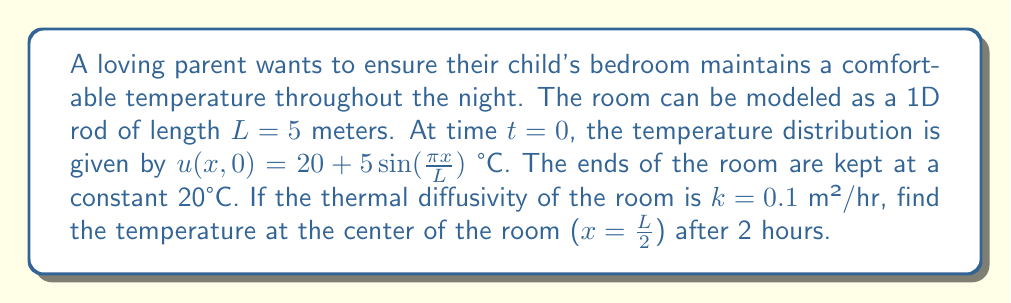Can you solve this math problem? To solve this problem, we'll use the heat equation in one dimension:

$$\frac{\partial u}{\partial t} = k\frac{\partial^2 u}{\partial x^2}$$

Given conditions:
- Initial condition: $u(x,0) = 20 + 5\sin(\frac{\pi x}{L})$
- Boundary conditions: $u(0,t) = u(L,t) = 20$
- $L = 5$ m, $k = 0.1$ m²/hr, $t = 2$ hr, $x = \frac{L}{2} = 2.5$ m

Step 1: The solution to the heat equation with these boundary conditions is:

$$u(x,t) = 20 + \sum_{n=1}^{\infty} B_n \sin(\frac{n\pi x}{L})e^{-k(\frac{n\pi}{L})^2t}$$

Step 2: Find $B_n$ using the initial condition:

$$B_n = \frac{2}{L}\int_0^L (u(x,0) - 20)\sin(\frac{n\pi x}{L})dx$$

$$B_n = \frac{2}{L}\int_0^L 5\sin(\frac{\pi x}{L})\sin(\frac{n\pi x}{L})dx$$

This integral is non-zero only when $n=1$, giving $B_1 = 5$ and $B_n = 0$ for $n > 1$.

Step 3: Simplify the solution:

$$u(x,t) = 20 + 5\sin(\frac{\pi x}{L})e^{-k(\frac{\pi}{L})^2t}$$

Step 4: Calculate the temperature at $x=\frac{L}{2}$ and $t=2$:

$$u(\frac{L}{2},2) = 20 + 5\sin(\frac{\pi}{2})e^{-0.1(\frac{\pi}{5})^2 \cdot 2}$$

$$u(\frac{L}{2},2) = 20 + 5 \cdot e^{-0.0789}$$

$$u(\frac{L}{2},2) \approx 24.62°C$$
Answer: 24.62°C 